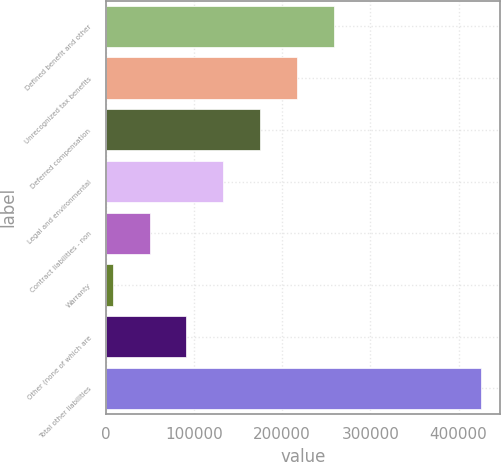Convert chart. <chart><loc_0><loc_0><loc_500><loc_500><bar_chart><fcel>Defined benefit and other<fcel>Unrecognized tax benefits<fcel>Deferred compensation<fcel>Legal and environmental<fcel>Contract liabilities - non<fcel>Warranty<fcel>Other (none of which are<fcel>Total other liabilities<nl><fcel>258546<fcel>216796<fcel>175045<fcel>133294<fcel>49793.5<fcel>8043<fcel>91544<fcel>425548<nl></chart> 